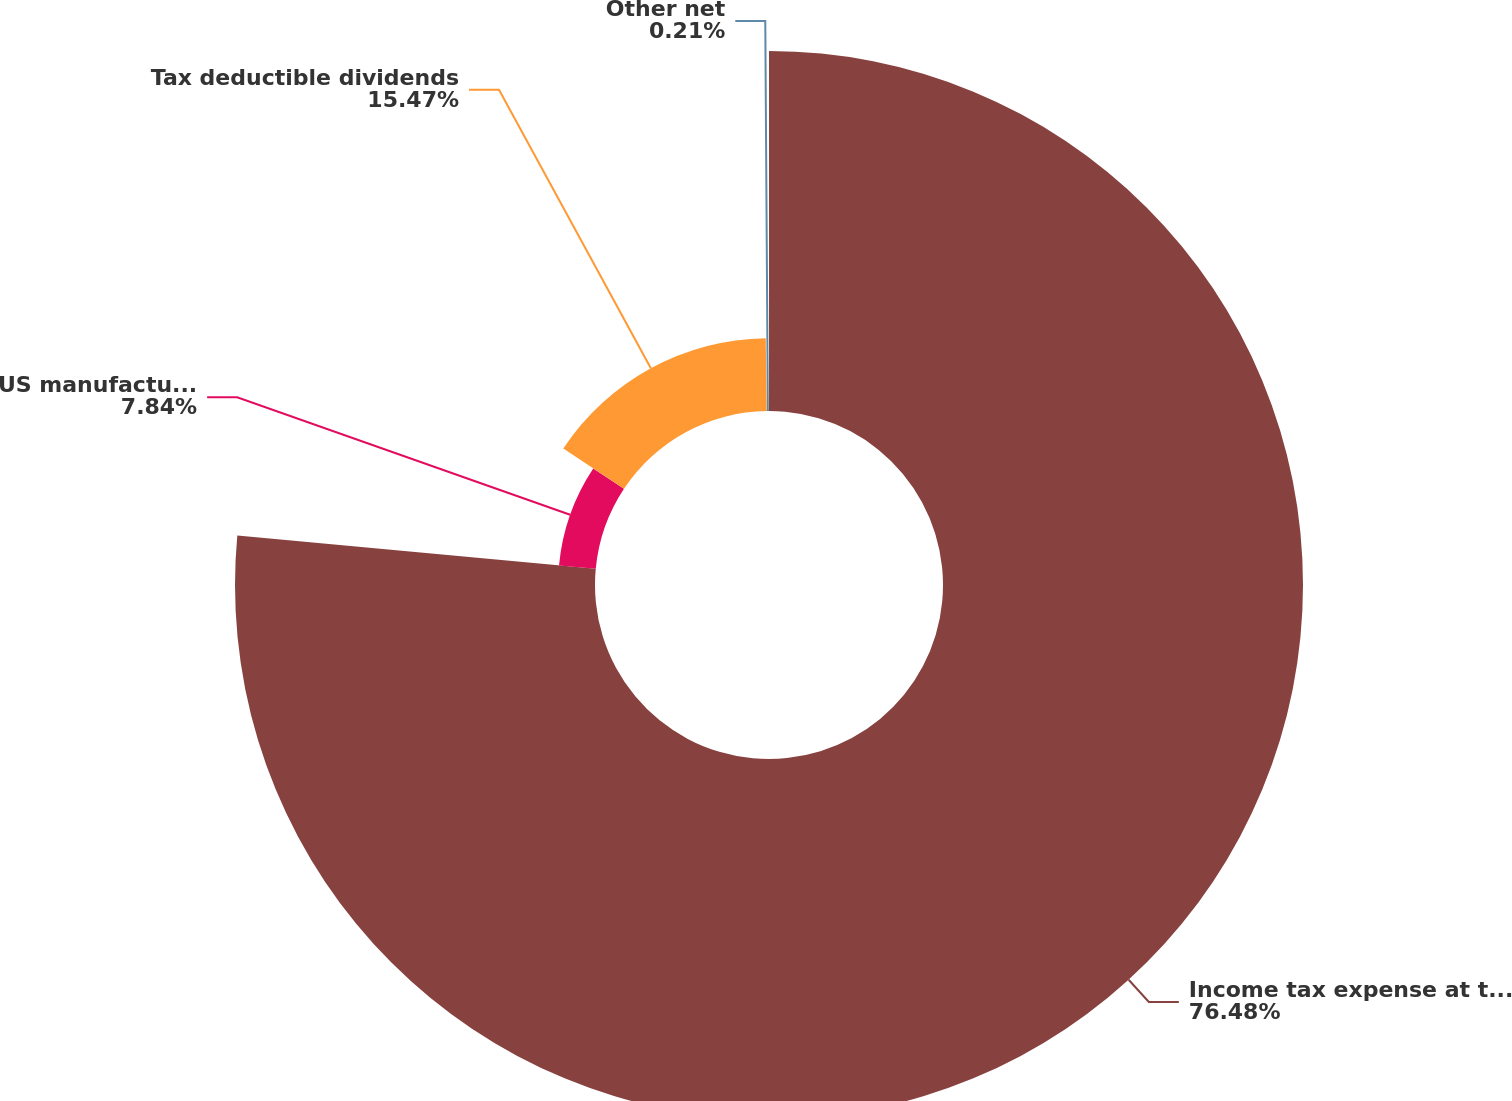<chart> <loc_0><loc_0><loc_500><loc_500><pie_chart><fcel>Income tax expense at the US<fcel>US manufacturing deduction<fcel>Tax deductible dividends<fcel>Other net<nl><fcel>76.48%<fcel>7.84%<fcel>15.47%<fcel>0.21%<nl></chart> 